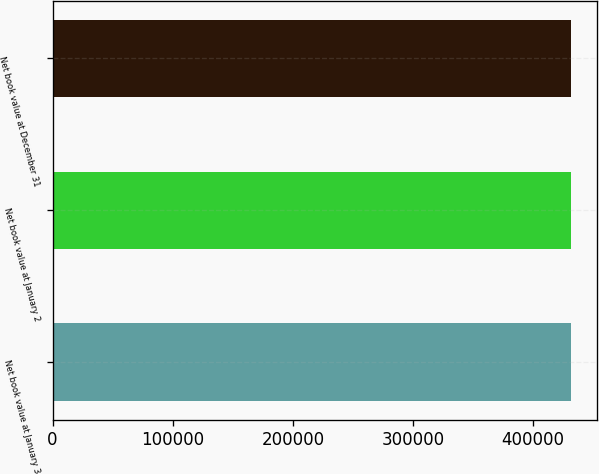Convert chart. <chart><loc_0><loc_0><loc_500><loc_500><bar_chart><fcel>Net book value at January 3<fcel>Net book value at January 2<fcel>Net book value at December 31<nl><fcel>431561<fcel>431561<fcel>431561<nl></chart> 